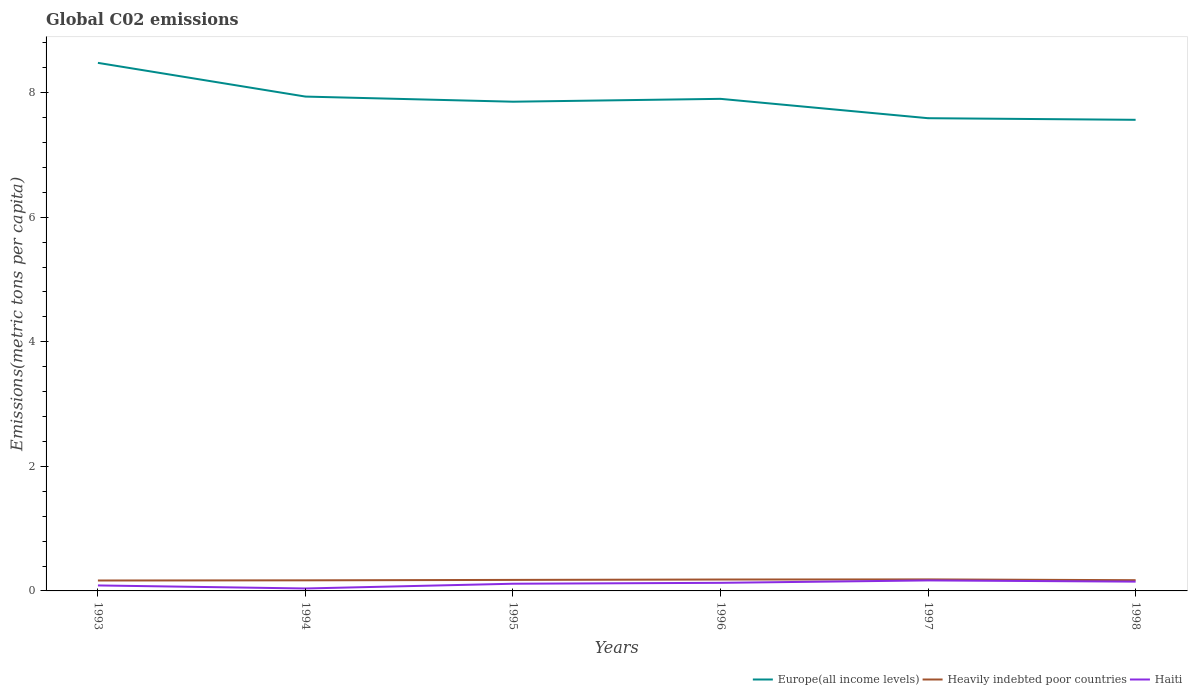Does the line corresponding to Europe(all income levels) intersect with the line corresponding to Heavily indebted poor countries?
Offer a terse response. No. Across all years, what is the maximum amount of CO2 emitted in in Europe(all income levels)?
Your answer should be compact. 7.56. What is the total amount of CO2 emitted in in Haiti in the graph?
Give a very brief answer. -0.01. What is the difference between the highest and the second highest amount of CO2 emitted in in Haiti?
Provide a succinct answer. 0.13. What is the difference between the highest and the lowest amount of CO2 emitted in in Europe(all income levels)?
Give a very brief answer. 3. How many lines are there?
Make the answer very short. 3. What is the difference between two consecutive major ticks on the Y-axis?
Give a very brief answer. 2. Are the values on the major ticks of Y-axis written in scientific E-notation?
Provide a short and direct response. No. Does the graph contain grids?
Keep it short and to the point. No. How many legend labels are there?
Provide a short and direct response. 3. How are the legend labels stacked?
Offer a very short reply. Horizontal. What is the title of the graph?
Offer a terse response. Global C02 emissions. Does "Norway" appear as one of the legend labels in the graph?
Offer a very short reply. No. What is the label or title of the X-axis?
Provide a short and direct response. Years. What is the label or title of the Y-axis?
Your response must be concise. Emissions(metric tons per capita). What is the Emissions(metric tons per capita) of Europe(all income levels) in 1993?
Your answer should be very brief. 8.48. What is the Emissions(metric tons per capita) of Heavily indebted poor countries in 1993?
Make the answer very short. 0.17. What is the Emissions(metric tons per capita) in Haiti in 1993?
Ensure brevity in your answer.  0.09. What is the Emissions(metric tons per capita) of Europe(all income levels) in 1994?
Make the answer very short. 7.94. What is the Emissions(metric tons per capita) in Heavily indebted poor countries in 1994?
Provide a short and direct response. 0.17. What is the Emissions(metric tons per capita) in Haiti in 1994?
Offer a terse response. 0.04. What is the Emissions(metric tons per capita) in Europe(all income levels) in 1995?
Offer a terse response. 7.85. What is the Emissions(metric tons per capita) of Heavily indebted poor countries in 1995?
Your answer should be very brief. 0.18. What is the Emissions(metric tons per capita) of Haiti in 1995?
Offer a terse response. 0.12. What is the Emissions(metric tons per capita) in Europe(all income levels) in 1996?
Make the answer very short. 7.9. What is the Emissions(metric tons per capita) in Heavily indebted poor countries in 1996?
Your answer should be very brief. 0.18. What is the Emissions(metric tons per capita) of Haiti in 1996?
Your answer should be very brief. 0.13. What is the Emissions(metric tons per capita) of Europe(all income levels) in 1997?
Give a very brief answer. 7.59. What is the Emissions(metric tons per capita) of Heavily indebted poor countries in 1997?
Keep it short and to the point. 0.18. What is the Emissions(metric tons per capita) of Haiti in 1997?
Offer a very short reply. 0.17. What is the Emissions(metric tons per capita) in Europe(all income levels) in 1998?
Your answer should be compact. 7.56. What is the Emissions(metric tons per capita) in Heavily indebted poor countries in 1998?
Provide a succinct answer. 0.17. What is the Emissions(metric tons per capita) in Haiti in 1998?
Make the answer very short. 0.15. Across all years, what is the maximum Emissions(metric tons per capita) of Europe(all income levels)?
Your answer should be very brief. 8.48. Across all years, what is the maximum Emissions(metric tons per capita) in Heavily indebted poor countries?
Make the answer very short. 0.18. Across all years, what is the maximum Emissions(metric tons per capita) in Haiti?
Provide a succinct answer. 0.17. Across all years, what is the minimum Emissions(metric tons per capita) of Europe(all income levels)?
Your answer should be very brief. 7.56. Across all years, what is the minimum Emissions(metric tons per capita) in Heavily indebted poor countries?
Your response must be concise. 0.17. Across all years, what is the minimum Emissions(metric tons per capita) in Haiti?
Make the answer very short. 0.04. What is the total Emissions(metric tons per capita) of Europe(all income levels) in the graph?
Your answer should be very brief. 47.32. What is the total Emissions(metric tons per capita) in Heavily indebted poor countries in the graph?
Keep it short and to the point. 1.05. What is the total Emissions(metric tons per capita) in Haiti in the graph?
Ensure brevity in your answer.  0.69. What is the difference between the Emissions(metric tons per capita) of Europe(all income levels) in 1993 and that in 1994?
Your answer should be compact. 0.54. What is the difference between the Emissions(metric tons per capita) in Heavily indebted poor countries in 1993 and that in 1994?
Make the answer very short. -0. What is the difference between the Emissions(metric tons per capita) in Haiti in 1993 and that in 1994?
Offer a terse response. 0.05. What is the difference between the Emissions(metric tons per capita) in Europe(all income levels) in 1993 and that in 1995?
Your answer should be very brief. 0.62. What is the difference between the Emissions(metric tons per capita) in Heavily indebted poor countries in 1993 and that in 1995?
Your response must be concise. -0.01. What is the difference between the Emissions(metric tons per capita) of Haiti in 1993 and that in 1995?
Ensure brevity in your answer.  -0.03. What is the difference between the Emissions(metric tons per capita) in Europe(all income levels) in 1993 and that in 1996?
Your answer should be very brief. 0.58. What is the difference between the Emissions(metric tons per capita) of Heavily indebted poor countries in 1993 and that in 1996?
Give a very brief answer. -0.02. What is the difference between the Emissions(metric tons per capita) of Haiti in 1993 and that in 1996?
Your response must be concise. -0.04. What is the difference between the Emissions(metric tons per capita) of Europe(all income levels) in 1993 and that in 1997?
Make the answer very short. 0.89. What is the difference between the Emissions(metric tons per capita) in Heavily indebted poor countries in 1993 and that in 1997?
Make the answer very short. -0.02. What is the difference between the Emissions(metric tons per capita) in Haiti in 1993 and that in 1997?
Provide a succinct answer. -0.08. What is the difference between the Emissions(metric tons per capita) in Europe(all income levels) in 1993 and that in 1998?
Offer a terse response. 0.91. What is the difference between the Emissions(metric tons per capita) in Heavily indebted poor countries in 1993 and that in 1998?
Offer a very short reply. -0. What is the difference between the Emissions(metric tons per capita) in Haiti in 1993 and that in 1998?
Keep it short and to the point. -0.06. What is the difference between the Emissions(metric tons per capita) in Europe(all income levels) in 1994 and that in 1995?
Provide a short and direct response. 0.08. What is the difference between the Emissions(metric tons per capita) of Heavily indebted poor countries in 1994 and that in 1995?
Your answer should be compact. -0.01. What is the difference between the Emissions(metric tons per capita) of Haiti in 1994 and that in 1995?
Keep it short and to the point. -0.08. What is the difference between the Emissions(metric tons per capita) of Europe(all income levels) in 1994 and that in 1996?
Your answer should be very brief. 0.04. What is the difference between the Emissions(metric tons per capita) of Heavily indebted poor countries in 1994 and that in 1996?
Your answer should be very brief. -0.01. What is the difference between the Emissions(metric tons per capita) in Haiti in 1994 and that in 1996?
Provide a succinct answer. -0.09. What is the difference between the Emissions(metric tons per capita) of Europe(all income levels) in 1994 and that in 1997?
Ensure brevity in your answer.  0.35. What is the difference between the Emissions(metric tons per capita) of Heavily indebted poor countries in 1994 and that in 1997?
Give a very brief answer. -0.01. What is the difference between the Emissions(metric tons per capita) of Haiti in 1994 and that in 1997?
Your answer should be compact. -0.13. What is the difference between the Emissions(metric tons per capita) in Europe(all income levels) in 1994 and that in 1998?
Give a very brief answer. 0.37. What is the difference between the Emissions(metric tons per capita) in Heavily indebted poor countries in 1994 and that in 1998?
Offer a very short reply. -0. What is the difference between the Emissions(metric tons per capita) of Haiti in 1994 and that in 1998?
Offer a terse response. -0.11. What is the difference between the Emissions(metric tons per capita) of Europe(all income levels) in 1995 and that in 1996?
Provide a succinct answer. -0.05. What is the difference between the Emissions(metric tons per capita) of Heavily indebted poor countries in 1995 and that in 1996?
Ensure brevity in your answer.  -0.01. What is the difference between the Emissions(metric tons per capita) in Haiti in 1995 and that in 1996?
Offer a terse response. -0.01. What is the difference between the Emissions(metric tons per capita) in Europe(all income levels) in 1995 and that in 1997?
Offer a very short reply. 0.27. What is the difference between the Emissions(metric tons per capita) in Heavily indebted poor countries in 1995 and that in 1997?
Your response must be concise. -0.01. What is the difference between the Emissions(metric tons per capita) in Haiti in 1995 and that in 1997?
Your response must be concise. -0.05. What is the difference between the Emissions(metric tons per capita) in Europe(all income levels) in 1995 and that in 1998?
Offer a very short reply. 0.29. What is the difference between the Emissions(metric tons per capita) in Heavily indebted poor countries in 1995 and that in 1998?
Give a very brief answer. 0. What is the difference between the Emissions(metric tons per capita) of Haiti in 1995 and that in 1998?
Provide a succinct answer. -0.03. What is the difference between the Emissions(metric tons per capita) of Europe(all income levels) in 1996 and that in 1997?
Keep it short and to the point. 0.31. What is the difference between the Emissions(metric tons per capita) of Heavily indebted poor countries in 1996 and that in 1997?
Offer a very short reply. -0. What is the difference between the Emissions(metric tons per capita) in Haiti in 1996 and that in 1997?
Your answer should be very brief. -0.04. What is the difference between the Emissions(metric tons per capita) in Europe(all income levels) in 1996 and that in 1998?
Keep it short and to the point. 0.34. What is the difference between the Emissions(metric tons per capita) of Heavily indebted poor countries in 1996 and that in 1998?
Offer a very short reply. 0.01. What is the difference between the Emissions(metric tons per capita) of Haiti in 1996 and that in 1998?
Your answer should be compact. -0.02. What is the difference between the Emissions(metric tons per capita) of Europe(all income levels) in 1997 and that in 1998?
Ensure brevity in your answer.  0.03. What is the difference between the Emissions(metric tons per capita) in Heavily indebted poor countries in 1997 and that in 1998?
Your answer should be very brief. 0.01. What is the difference between the Emissions(metric tons per capita) in Haiti in 1997 and that in 1998?
Offer a terse response. 0.02. What is the difference between the Emissions(metric tons per capita) in Europe(all income levels) in 1993 and the Emissions(metric tons per capita) in Heavily indebted poor countries in 1994?
Give a very brief answer. 8.31. What is the difference between the Emissions(metric tons per capita) in Europe(all income levels) in 1993 and the Emissions(metric tons per capita) in Haiti in 1994?
Ensure brevity in your answer.  8.44. What is the difference between the Emissions(metric tons per capita) in Heavily indebted poor countries in 1993 and the Emissions(metric tons per capita) in Haiti in 1994?
Give a very brief answer. 0.13. What is the difference between the Emissions(metric tons per capita) in Europe(all income levels) in 1993 and the Emissions(metric tons per capita) in Heavily indebted poor countries in 1995?
Provide a succinct answer. 8.3. What is the difference between the Emissions(metric tons per capita) in Europe(all income levels) in 1993 and the Emissions(metric tons per capita) in Haiti in 1995?
Your response must be concise. 8.36. What is the difference between the Emissions(metric tons per capita) of Heavily indebted poor countries in 1993 and the Emissions(metric tons per capita) of Haiti in 1995?
Your answer should be very brief. 0.05. What is the difference between the Emissions(metric tons per capita) of Europe(all income levels) in 1993 and the Emissions(metric tons per capita) of Heavily indebted poor countries in 1996?
Your response must be concise. 8.3. What is the difference between the Emissions(metric tons per capita) in Europe(all income levels) in 1993 and the Emissions(metric tons per capita) in Haiti in 1996?
Ensure brevity in your answer.  8.35. What is the difference between the Emissions(metric tons per capita) in Heavily indebted poor countries in 1993 and the Emissions(metric tons per capita) in Haiti in 1996?
Ensure brevity in your answer.  0.04. What is the difference between the Emissions(metric tons per capita) of Europe(all income levels) in 1993 and the Emissions(metric tons per capita) of Heavily indebted poor countries in 1997?
Your response must be concise. 8.29. What is the difference between the Emissions(metric tons per capita) of Europe(all income levels) in 1993 and the Emissions(metric tons per capita) of Haiti in 1997?
Make the answer very short. 8.31. What is the difference between the Emissions(metric tons per capita) of Heavily indebted poor countries in 1993 and the Emissions(metric tons per capita) of Haiti in 1997?
Give a very brief answer. -0. What is the difference between the Emissions(metric tons per capita) in Europe(all income levels) in 1993 and the Emissions(metric tons per capita) in Heavily indebted poor countries in 1998?
Your response must be concise. 8.31. What is the difference between the Emissions(metric tons per capita) of Europe(all income levels) in 1993 and the Emissions(metric tons per capita) of Haiti in 1998?
Make the answer very short. 8.33. What is the difference between the Emissions(metric tons per capita) in Heavily indebted poor countries in 1993 and the Emissions(metric tons per capita) in Haiti in 1998?
Your answer should be compact. 0.02. What is the difference between the Emissions(metric tons per capita) of Europe(all income levels) in 1994 and the Emissions(metric tons per capita) of Heavily indebted poor countries in 1995?
Your response must be concise. 7.76. What is the difference between the Emissions(metric tons per capita) in Europe(all income levels) in 1994 and the Emissions(metric tons per capita) in Haiti in 1995?
Make the answer very short. 7.82. What is the difference between the Emissions(metric tons per capita) in Heavily indebted poor countries in 1994 and the Emissions(metric tons per capita) in Haiti in 1995?
Make the answer very short. 0.05. What is the difference between the Emissions(metric tons per capita) in Europe(all income levels) in 1994 and the Emissions(metric tons per capita) in Heavily indebted poor countries in 1996?
Your answer should be compact. 7.75. What is the difference between the Emissions(metric tons per capita) in Europe(all income levels) in 1994 and the Emissions(metric tons per capita) in Haiti in 1996?
Offer a terse response. 7.81. What is the difference between the Emissions(metric tons per capita) in Heavily indebted poor countries in 1994 and the Emissions(metric tons per capita) in Haiti in 1996?
Your response must be concise. 0.04. What is the difference between the Emissions(metric tons per capita) of Europe(all income levels) in 1994 and the Emissions(metric tons per capita) of Heavily indebted poor countries in 1997?
Your answer should be compact. 7.75. What is the difference between the Emissions(metric tons per capita) in Europe(all income levels) in 1994 and the Emissions(metric tons per capita) in Haiti in 1997?
Provide a succinct answer. 7.77. What is the difference between the Emissions(metric tons per capita) of Heavily indebted poor countries in 1994 and the Emissions(metric tons per capita) of Haiti in 1997?
Give a very brief answer. 0. What is the difference between the Emissions(metric tons per capita) of Europe(all income levels) in 1994 and the Emissions(metric tons per capita) of Heavily indebted poor countries in 1998?
Ensure brevity in your answer.  7.76. What is the difference between the Emissions(metric tons per capita) in Europe(all income levels) in 1994 and the Emissions(metric tons per capita) in Haiti in 1998?
Keep it short and to the point. 7.79. What is the difference between the Emissions(metric tons per capita) of Heavily indebted poor countries in 1994 and the Emissions(metric tons per capita) of Haiti in 1998?
Provide a succinct answer. 0.02. What is the difference between the Emissions(metric tons per capita) in Europe(all income levels) in 1995 and the Emissions(metric tons per capita) in Heavily indebted poor countries in 1996?
Your response must be concise. 7.67. What is the difference between the Emissions(metric tons per capita) in Europe(all income levels) in 1995 and the Emissions(metric tons per capita) in Haiti in 1996?
Your answer should be very brief. 7.72. What is the difference between the Emissions(metric tons per capita) in Heavily indebted poor countries in 1995 and the Emissions(metric tons per capita) in Haiti in 1996?
Your answer should be compact. 0.05. What is the difference between the Emissions(metric tons per capita) of Europe(all income levels) in 1995 and the Emissions(metric tons per capita) of Heavily indebted poor countries in 1997?
Keep it short and to the point. 7.67. What is the difference between the Emissions(metric tons per capita) in Europe(all income levels) in 1995 and the Emissions(metric tons per capita) in Haiti in 1997?
Your answer should be very brief. 7.69. What is the difference between the Emissions(metric tons per capita) in Heavily indebted poor countries in 1995 and the Emissions(metric tons per capita) in Haiti in 1997?
Ensure brevity in your answer.  0.01. What is the difference between the Emissions(metric tons per capita) of Europe(all income levels) in 1995 and the Emissions(metric tons per capita) of Heavily indebted poor countries in 1998?
Ensure brevity in your answer.  7.68. What is the difference between the Emissions(metric tons per capita) in Europe(all income levels) in 1995 and the Emissions(metric tons per capita) in Haiti in 1998?
Your answer should be compact. 7.71. What is the difference between the Emissions(metric tons per capita) of Heavily indebted poor countries in 1995 and the Emissions(metric tons per capita) of Haiti in 1998?
Keep it short and to the point. 0.03. What is the difference between the Emissions(metric tons per capita) of Europe(all income levels) in 1996 and the Emissions(metric tons per capita) of Heavily indebted poor countries in 1997?
Your answer should be very brief. 7.72. What is the difference between the Emissions(metric tons per capita) in Europe(all income levels) in 1996 and the Emissions(metric tons per capita) in Haiti in 1997?
Give a very brief answer. 7.73. What is the difference between the Emissions(metric tons per capita) in Heavily indebted poor countries in 1996 and the Emissions(metric tons per capita) in Haiti in 1997?
Provide a succinct answer. 0.01. What is the difference between the Emissions(metric tons per capita) of Europe(all income levels) in 1996 and the Emissions(metric tons per capita) of Heavily indebted poor countries in 1998?
Ensure brevity in your answer.  7.73. What is the difference between the Emissions(metric tons per capita) in Europe(all income levels) in 1996 and the Emissions(metric tons per capita) in Haiti in 1998?
Provide a short and direct response. 7.75. What is the difference between the Emissions(metric tons per capita) in Heavily indebted poor countries in 1996 and the Emissions(metric tons per capita) in Haiti in 1998?
Ensure brevity in your answer.  0.03. What is the difference between the Emissions(metric tons per capita) in Europe(all income levels) in 1997 and the Emissions(metric tons per capita) in Heavily indebted poor countries in 1998?
Provide a short and direct response. 7.42. What is the difference between the Emissions(metric tons per capita) in Europe(all income levels) in 1997 and the Emissions(metric tons per capita) in Haiti in 1998?
Ensure brevity in your answer.  7.44. What is the difference between the Emissions(metric tons per capita) of Heavily indebted poor countries in 1997 and the Emissions(metric tons per capita) of Haiti in 1998?
Provide a short and direct response. 0.04. What is the average Emissions(metric tons per capita) in Europe(all income levels) per year?
Your response must be concise. 7.89. What is the average Emissions(metric tons per capita) in Heavily indebted poor countries per year?
Make the answer very short. 0.18. What is the average Emissions(metric tons per capita) in Haiti per year?
Give a very brief answer. 0.12. In the year 1993, what is the difference between the Emissions(metric tons per capita) in Europe(all income levels) and Emissions(metric tons per capita) in Heavily indebted poor countries?
Give a very brief answer. 8.31. In the year 1993, what is the difference between the Emissions(metric tons per capita) in Europe(all income levels) and Emissions(metric tons per capita) in Haiti?
Provide a succinct answer. 8.39. In the year 1993, what is the difference between the Emissions(metric tons per capita) of Heavily indebted poor countries and Emissions(metric tons per capita) of Haiti?
Offer a very short reply. 0.08. In the year 1994, what is the difference between the Emissions(metric tons per capita) of Europe(all income levels) and Emissions(metric tons per capita) of Heavily indebted poor countries?
Provide a short and direct response. 7.77. In the year 1994, what is the difference between the Emissions(metric tons per capita) of Europe(all income levels) and Emissions(metric tons per capita) of Haiti?
Your answer should be very brief. 7.9. In the year 1994, what is the difference between the Emissions(metric tons per capita) of Heavily indebted poor countries and Emissions(metric tons per capita) of Haiti?
Provide a short and direct response. 0.13. In the year 1995, what is the difference between the Emissions(metric tons per capita) of Europe(all income levels) and Emissions(metric tons per capita) of Heavily indebted poor countries?
Keep it short and to the point. 7.68. In the year 1995, what is the difference between the Emissions(metric tons per capita) in Europe(all income levels) and Emissions(metric tons per capita) in Haiti?
Offer a very short reply. 7.74. In the year 1995, what is the difference between the Emissions(metric tons per capita) of Heavily indebted poor countries and Emissions(metric tons per capita) of Haiti?
Ensure brevity in your answer.  0.06. In the year 1996, what is the difference between the Emissions(metric tons per capita) in Europe(all income levels) and Emissions(metric tons per capita) in Heavily indebted poor countries?
Ensure brevity in your answer.  7.72. In the year 1996, what is the difference between the Emissions(metric tons per capita) of Europe(all income levels) and Emissions(metric tons per capita) of Haiti?
Offer a terse response. 7.77. In the year 1996, what is the difference between the Emissions(metric tons per capita) of Heavily indebted poor countries and Emissions(metric tons per capita) of Haiti?
Your answer should be compact. 0.05. In the year 1997, what is the difference between the Emissions(metric tons per capita) in Europe(all income levels) and Emissions(metric tons per capita) in Heavily indebted poor countries?
Give a very brief answer. 7.4. In the year 1997, what is the difference between the Emissions(metric tons per capita) in Europe(all income levels) and Emissions(metric tons per capita) in Haiti?
Provide a succinct answer. 7.42. In the year 1997, what is the difference between the Emissions(metric tons per capita) of Heavily indebted poor countries and Emissions(metric tons per capita) of Haiti?
Ensure brevity in your answer.  0.02. In the year 1998, what is the difference between the Emissions(metric tons per capita) of Europe(all income levels) and Emissions(metric tons per capita) of Heavily indebted poor countries?
Offer a very short reply. 7.39. In the year 1998, what is the difference between the Emissions(metric tons per capita) in Europe(all income levels) and Emissions(metric tons per capita) in Haiti?
Keep it short and to the point. 7.41. In the year 1998, what is the difference between the Emissions(metric tons per capita) of Heavily indebted poor countries and Emissions(metric tons per capita) of Haiti?
Your response must be concise. 0.02. What is the ratio of the Emissions(metric tons per capita) in Europe(all income levels) in 1993 to that in 1994?
Offer a terse response. 1.07. What is the ratio of the Emissions(metric tons per capita) in Heavily indebted poor countries in 1993 to that in 1994?
Make the answer very short. 0.98. What is the ratio of the Emissions(metric tons per capita) in Haiti in 1993 to that in 1994?
Provide a short and direct response. 2.25. What is the ratio of the Emissions(metric tons per capita) in Europe(all income levels) in 1993 to that in 1995?
Keep it short and to the point. 1.08. What is the ratio of the Emissions(metric tons per capita) in Heavily indebted poor countries in 1993 to that in 1995?
Your answer should be compact. 0.95. What is the ratio of the Emissions(metric tons per capita) of Haiti in 1993 to that in 1995?
Make the answer very short. 0.76. What is the ratio of the Emissions(metric tons per capita) in Europe(all income levels) in 1993 to that in 1996?
Make the answer very short. 1.07. What is the ratio of the Emissions(metric tons per capita) in Heavily indebted poor countries in 1993 to that in 1996?
Your response must be concise. 0.91. What is the ratio of the Emissions(metric tons per capita) of Haiti in 1993 to that in 1996?
Provide a succinct answer. 0.68. What is the ratio of the Emissions(metric tons per capita) of Europe(all income levels) in 1993 to that in 1997?
Give a very brief answer. 1.12. What is the ratio of the Emissions(metric tons per capita) in Heavily indebted poor countries in 1993 to that in 1997?
Provide a succinct answer. 0.91. What is the ratio of the Emissions(metric tons per capita) in Haiti in 1993 to that in 1997?
Give a very brief answer. 0.52. What is the ratio of the Emissions(metric tons per capita) of Europe(all income levels) in 1993 to that in 1998?
Your answer should be compact. 1.12. What is the ratio of the Emissions(metric tons per capita) of Heavily indebted poor countries in 1993 to that in 1998?
Your answer should be very brief. 0.97. What is the ratio of the Emissions(metric tons per capita) in Haiti in 1993 to that in 1998?
Your response must be concise. 0.59. What is the ratio of the Emissions(metric tons per capita) in Europe(all income levels) in 1994 to that in 1995?
Offer a terse response. 1.01. What is the ratio of the Emissions(metric tons per capita) in Heavily indebted poor countries in 1994 to that in 1995?
Your response must be concise. 0.96. What is the ratio of the Emissions(metric tons per capita) of Haiti in 1994 to that in 1995?
Your answer should be very brief. 0.34. What is the ratio of the Emissions(metric tons per capita) of Heavily indebted poor countries in 1994 to that in 1996?
Ensure brevity in your answer.  0.93. What is the ratio of the Emissions(metric tons per capita) in Haiti in 1994 to that in 1996?
Ensure brevity in your answer.  0.3. What is the ratio of the Emissions(metric tons per capita) in Europe(all income levels) in 1994 to that in 1997?
Give a very brief answer. 1.05. What is the ratio of the Emissions(metric tons per capita) of Heavily indebted poor countries in 1994 to that in 1997?
Make the answer very short. 0.92. What is the ratio of the Emissions(metric tons per capita) of Haiti in 1994 to that in 1997?
Make the answer very short. 0.23. What is the ratio of the Emissions(metric tons per capita) of Europe(all income levels) in 1994 to that in 1998?
Give a very brief answer. 1.05. What is the ratio of the Emissions(metric tons per capita) in Heavily indebted poor countries in 1994 to that in 1998?
Your answer should be compact. 0.99. What is the ratio of the Emissions(metric tons per capita) in Haiti in 1994 to that in 1998?
Your answer should be compact. 0.26. What is the ratio of the Emissions(metric tons per capita) in Heavily indebted poor countries in 1995 to that in 1996?
Keep it short and to the point. 0.97. What is the ratio of the Emissions(metric tons per capita) of Haiti in 1995 to that in 1996?
Provide a short and direct response. 0.89. What is the ratio of the Emissions(metric tons per capita) in Europe(all income levels) in 1995 to that in 1997?
Your answer should be compact. 1.03. What is the ratio of the Emissions(metric tons per capita) in Heavily indebted poor countries in 1995 to that in 1997?
Provide a short and direct response. 0.96. What is the ratio of the Emissions(metric tons per capita) in Haiti in 1995 to that in 1997?
Your response must be concise. 0.68. What is the ratio of the Emissions(metric tons per capita) in Heavily indebted poor countries in 1995 to that in 1998?
Provide a short and direct response. 1.03. What is the ratio of the Emissions(metric tons per capita) in Haiti in 1995 to that in 1998?
Your response must be concise. 0.77. What is the ratio of the Emissions(metric tons per capita) in Europe(all income levels) in 1996 to that in 1997?
Offer a terse response. 1.04. What is the ratio of the Emissions(metric tons per capita) in Heavily indebted poor countries in 1996 to that in 1997?
Give a very brief answer. 0.99. What is the ratio of the Emissions(metric tons per capita) in Haiti in 1996 to that in 1997?
Your response must be concise. 0.77. What is the ratio of the Emissions(metric tons per capita) in Europe(all income levels) in 1996 to that in 1998?
Your answer should be compact. 1.04. What is the ratio of the Emissions(metric tons per capita) of Heavily indebted poor countries in 1996 to that in 1998?
Provide a succinct answer. 1.06. What is the ratio of the Emissions(metric tons per capita) of Haiti in 1996 to that in 1998?
Make the answer very short. 0.87. What is the ratio of the Emissions(metric tons per capita) of Heavily indebted poor countries in 1997 to that in 1998?
Your answer should be very brief. 1.07. What is the ratio of the Emissions(metric tons per capita) in Haiti in 1997 to that in 1998?
Your answer should be compact. 1.13. What is the difference between the highest and the second highest Emissions(metric tons per capita) of Europe(all income levels)?
Provide a succinct answer. 0.54. What is the difference between the highest and the second highest Emissions(metric tons per capita) of Heavily indebted poor countries?
Your response must be concise. 0. What is the difference between the highest and the second highest Emissions(metric tons per capita) in Haiti?
Provide a succinct answer. 0.02. What is the difference between the highest and the lowest Emissions(metric tons per capita) of Europe(all income levels)?
Offer a very short reply. 0.91. What is the difference between the highest and the lowest Emissions(metric tons per capita) of Heavily indebted poor countries?
Your answer should be very brief. 0.02. What is the difference between the highest and the lowest Emissions(metric tons per capita) in Haiti?
Offer a terse response. 0.13. 